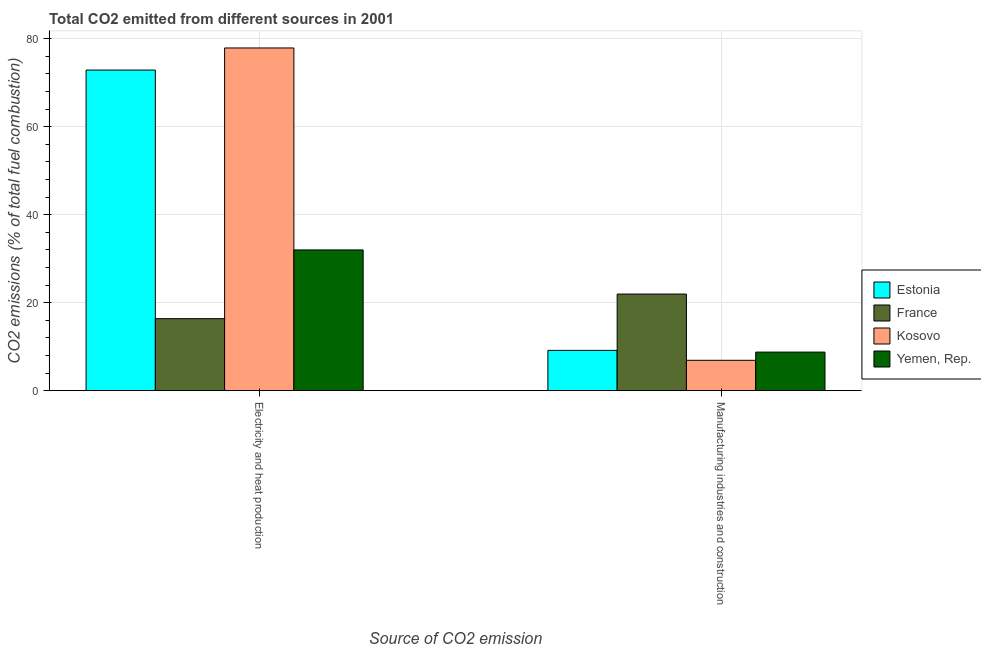How many different coloured bars are there?
Ensure brevity in your answer.  4. How many groups of bars are there?
Make the answer very short. 2. Are the number of bars per tick equal to the number of legend labels?
Your answer should be very brief. Yes. How many bars are there on the 2nd tick from the left?
Ensure brevity in your answer.  4. What is the label of the 2nd group of bars from the left?
Make the answer very short. Manufacturing industries and construction. What is the co2 emissions due to manufacturing industries in Yemen, Rep.?
Offer a very short reply. 8.76. Across all countries, what is the maximum co2 emissions due to manufacturing industries?
Provide a short and direct response. 21.96. Across all countries, what is the minimum co2 emissions due to electricity and heat production?
Provide a succinct answer. 16.36. In which country was the co2 emissions due to electricity and heat production maximum?
Ensure brevity in your answer.  Kosovo. What is the total co2 emissions due to electricity and heat production in the graph?
Your answer should be very brief. 199.13. What is the difference between the co2 emissions due to electricity and heat production in Kosovo and that in Estonia?
Ensure brevity in your answer.  5.02. What is the difference between the co2 emissions due to electricity and heat production in Estonia and the co2 emissions due to manufacturing industries in Yemen, Rep.?
Keep it short and to the point. 64.12. What is the average co2 emissions due to manufacturing industries per country?
Give a very brief answer. 11.69. What is the difference between the co2 emissions due to electricity and heat production and co2 emissions due to manufacturing industries in Kosovo?
Keep it short and to the point. 71. What is the ratio of the co2 emissions due to electricity and heat production in France to that in Kosovo?
Make the answer very short. 0.21. In how many countries, is the co2 emissions due to electricity and heat production greater than the average co2 emissions due to electricity and heat production taken over all countries?
Provide a short and direct response. 2. What does the 4th bar from the left in Electricity and heat production represents?
Your answer should be compact. Yemen, Rep. What does the 1st bar from the right in Manufacturing industries and construction represents?
Give a very brief answer. Yemen, Rep. What is the difference between two consecutive major ticks on the Y-axis?
Give a very brief answer. 20. Does the graph contain any zero values?
Keep it short and to the point. No. Where does the legend appear in the graph?
Your answer should be very brief. Center right. How many legend labels are there?
Provide a succinct answer. 4. What is the title of the graph?
Your answer should be very brief. Total CO2 emitted from different sources in 2001. Does "Kuwait" appear as one of the legend labels in the graph?
Give a very brief answer. No. What is the label or title of the X-axis?
Offer a very short reply. Source of CO2 emission. What is the label or title of the Y-axis?
Give a very brief answer. CO2 emissions (% of total fuel combustion). What is the CO2 emissions (% of total fuel combustion) in Estonia in Electricity and heat production?
Your response must be concise. 72.88. What is the CO2 emissions (% of total fuel combustion) of France in Electricity and heat production?
Offer a terse response. 16.36. What is the CO2 emissions (% of total fuel combustion) in Kosovo in Electricity and heat production?
Make the answer very short. 77.9. What is the CO2 emissions (% of total fuel combustion) in Yemen, Rep. in Electricity and heat production?
Give a very brief answer. 31.99. What is the CO2 emissions (% of total fuel combustion) in Estonia in Manufacturing industries and construction?
Offer a terse response. 9.15. What is the CO2 emissions (% of total fuel combustion) in France in Manufacturing industries and construction?
Provide a short and direct response. 21.96. What is the CO2 emissions (% of total fuel combustion) of Kosovo in Manufacturing industries and construction?
Make the answer very short. 6.9. What is the CO2 emissions (% of total fuel combustion) of Yemen, Rep. in Manufacturing industries and construction?
Make the answer very short. 8.76. Across all Source of CO2 emission, what is the maximum CO2 emissions (% of total fuel combustion) in Estonia?
Provide a succinct answer. 72.88. Across all Source of CO2 emission, what is the maximum CO2 emissions (% of total fuel combustion) in France?
Your answer should be compact. 21.96. Across all Source of CO2 emission, what is the maximum CO2 emissions (% of total fuel combustion) of Kosovo?
Provide a short and direct response. 77.9. Across all Source of CO2 emission, what is the maximum CO2 emissions (% of total fuel combustion) in Yemen, Rep.?
Offer a very short reply. 31.99. Across all Source of CO2 emission, what is the minimum CO2 emissions (% of total fuel combustion) of Estonia?
Give a very brief answer. 9.15. Across all Source of CO2 emission, what is the minimum CO2 emissions (% of total fuel combustion) in France?
Offer a terse response. 16.36. Across all Source of CO2 emission, what is the minimum CO2 emissions (% of total fuel combustion) in Kosovo?
Provide a succinct answer. 6.9. Across all Source of CO2 emission, what is the minimum CO2 emissions (% of total fuel combustion) in Yemen, Rep.?
Keep it short and to the point. 8.76. What is the total CO2 emissions (% of total fuel combustion) of Estonia in the graph?
Your answer should be very brief. 82.03. What is the total CO2 emissions (% of total fuel combustion) in France in the graph?
Ensure brevity in your answer.  38.32. What is the total CO2 emissions (% of total fuel combustion) of Kosovo in the graph?
Your answer should be compact. 84.8. What is the total CO2 emissions (% of total fuel combustion) in Yemen, Rep. in the graph?
Offer a very short reply. 40.75. What is the difference between the CO2 emissions (% of total fuel combustion) in Estonia in Electricity and heat production and that in Manufacturing industries and construction?
Your response must be concise. 63.73. What is the difference between the CO2 emissions (% of total fuel combustion) of France in Electricity and heat production and that in Manufacturing industries and construction?
Your response must be concise. -5.6. What is the difference between the CO2 emissions (% of total fuel combustion) in Kosovo in Electricity and heat production and that in Manufacturing industries and construction?
Provide a short and direct response. 71. What is the difference between the CO2 emissions (% of total fuel combustion) in Yemen, Rep. in Electricity and heat production and that in Manufacturing industries and construction?
Provide a succinct answer. 23.23. What is the difference between the CO2 emissions (% of total fuel combustion) in Estonia in Electricity and heat production and the CO2 emissions (% of total fuel combustion) in France in Manufacturing industries and construction?
Offer a very short reply. 50.92. What is the difference between the CO2 emissions (% of total fuel combustion) of Estonia in Electricity and heat production and the CO2 emissions (% of total fuel combustion) of Kosovo in Manufacturing industries and construction?
Offer a terse response. 65.98. What is the difference between the CO2 emissions (% of total fuel combustion) in Estonia in Electricity and heat production and the CO2 emissions (% of total fuel combustion) in Yemen, Rep. in Manufacturing industries and construction?
Provide a short and direct response. 64.12. What is the difference between the CO2 emissions (% of total fuel combustion) of France in Electricity and heat production and the CO2 emissions (% of total fuel combustion) of Kosovo in Manufacturing industries and construction?
Make the answer very short. 9.47. What is the difference between the CO2 emissions (% of total fuel combustion) in France in Electricity and heat production and the CO2 emissions (% of total fuel combustion) in Yemen, Rep. in Manufacturing industries and construction?
Your answer should be compact. 7.6. What is the difference between the CO2 emissions (% of total fuel combustion) in Kosovo in Electricity and heat production and the CO2 emissions (% of total fuel combustion) in Yemen, Rep. in Manufacturing industries and construction?
Your response must be concise. 69.14. What is the average CO2 emissions (% of total fuel combustion) in Estonia per Source of CO2 emission?
Your response must be concise. 41.01. What is the average CO2 emissions (% of total fuel combustion) of France per Source of CO2 emission?
Offer a terse response. 19.16. What is the average CO2 emissions (% of total fuel combustion) of Kosovo per Source of CO2 emission?
Offer a very short reply. 42.4. What is the average CO2 emissions (% of total fuel combustion) of Yemen, Rep. per Source of CO2 emission?
Ensure brevity in your answer.  20.38. What is the difference between the CO2 emissions (% of total fuel combustion) of Estonia and CO2 emissions (% of total fuel combustion) of France in Electricity and heat production?
Your response must be concise. 56.51. What is the difference between the CO2 emissions (% of total fuel combustion) in Estonia and CO2 emissions (% of total fuel combustion) in Kosovo in Electricity and heat production?
Keep it short and to the point. -5.02. What is the difference between the CO2 emissions (% of total fuel combustion) of Estonia and CO2 emissions (% of total fuel combustion) of Yemen, Rep. in Electricity and heat production?
Provide a succinct answer. 40.89. What is the difference between the CO2 emissions (% of total fuel combustion) of France and CO2 emissions (% of total fuel combustion) of Kosovo in Electricity and heat production?
Give a very brief answer. -61.54. What is the difference between the CO2 emissions (% of total fuel combustion) in France and CO2 emissions (% of total fuel combustion) in Yemen, Rep. in Electricity and heat production?
Keep it short and to the point. -15.63. What is the difference between the CO2 emissions (% of total fuel combustion) of Kosovo and CO2 emissions (% of total fuel combustion) of Yemen, Rep. in Electricity and heat production?
Offer a terse response. 45.91. What is the difference between the CO2 emissions (% of total fuel combustion) of Estonia and CO2 emissions (% of total fuel combustion) of France in Manufacturing industries and construction?
Give a very brief answer. -12.81. What is the difference between the CO2 emissions (% of total fuel combustion) of Estonia and CO2 emissions (% of total fuel combustion) of Kosovo in Manufacturing industries and construction?
Provide a short and direct response. 2.25. What is the difference between the CO2 emissions (% of total fuel combustion) in Estonia and CO2 emissions (% of total fuel combustion) in Yemen, Rep. in Manufacturing industries and construction?
Ensure brevity in your answer.  0.39. What is the difference between the CO2 emissions (% of total fuel combustion) in France and CO2 emissions (% of total fuel combustion) in Kosovo in Manufacturing industries and construction?
Provide a short and direct response. 15.06. What is the difference between the CO2 emissions (% of total fuel combustion) in France and CO2 emissions (% of total fuel combustion) in Yemen, Rep. in Manufacturing industries and construction?
Keep it short and to the point. 13.2. What is the difference between the CO2 emissions (% of total fuel combustion) in Kosovo and CO2 emissions (% of total fuel combustion) in Yemen, Rep. in Manufacturing industries and construction?
Provide a short and direct response. -1.87. What is the ratio of the CO2 emissions (% of total fuel combustion) of Estonia in Electricity and heat production to that in Manufacturing industries and construction?
Your answer should be compact. 7.96. What is the ratio of the CO2 emissions (% of total fuel combustion) of France in Electricity and heat production to that in Manufacturing industries and construction?
Provide a short and direct response. 0.75. What is the ratio of the CO2 emissions (% of total fuel combustion) of Kosovo in Electricity and heat production to that in Manufacturing industries and construction?
Ensure brevity in your answer.  11.3. What is the ratio of the CO2 emissions (% of total fuel combustion) of Yemen, Rep. in Electricity and heat production to that in Manufacturing industries and construction?
Offer a terse response. 3.65. What is the difference between the highest and the second highest CO2 emissions (% of total fuel combustion) in Estonia?
Your answer should be very brief. 63.73. What is the difference between the highest and the second highest CO2 emissions (% of total fuel combustion) in France?
Your answer should be compact. 5.6. What is the difference between the highest and the second highest CO2 emissions (% of total fuel combustion) in Kosovo?
Keep it short and to the point. 71. What is the difference between the highest and the second highest CO2 emissions (% of total fuel combustion) in Yemen, Rep.?
Ensure brevity in your answer.  23.23. What is the difference between the highest and the lowest CO2 emissions (% of total fuel combustion) of Estonia?
Make the answer very short. 63.73. What is the difference between the highest and the lowest CO2 emissions (% of total fuel combustion) of France?
Provide a short and direct response. 5.6. What is the difference between the highest and the lowest CO2 emissions (% of total fuel combustion) of Kosovo?
Give a very brief answer. 71. What is the difference between the highest and the lowest CO2 emissions (% of total fuel combustion) of Yemen, Rep.?
Provide a short and direct response. 23.23. 